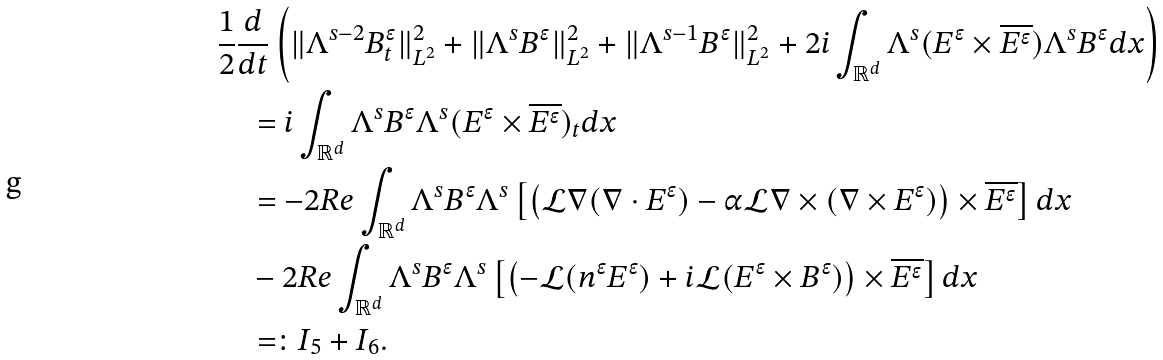<formula> <loc_0><loc_0><loc_500><loc_500>& \frac { 1 } { 2 } \frac { d } { d t } \left ( \| \Lambda ^ { s - 2 } B ^ { \epsilon } _ { t } \| _ { L ^ { 2 } } ^ { 2 } + \| \Lambda ^ { s } B ^ { \epsilon } \| _ { L ^ { 2 } } ^ { 2 } + \| \Lambda ^ { s - 1 } B ^ { \epsilon } \| _ { L ^ { 2 } } ^ { 2 } + 2 i \int _ { \mathbb { R } ^ { d } } \Lambda ^ { s } ( E ^ { \epsilon } \times \overline { E ^ { \epsilon } } ) \Lambda ^ { s } B ^ { \epsilon } d x \right ) \\ & \quad = i \int _ { \mathbb { R } ^ { d } } \Lambda ^ { s } B ^ { \epsilon } \Lambda ^ { s } ( E ^ { \epsilon } \times \overline { E ^ { \epsilon } } ) _ { t } d x \\ & \quad = - 2 R e \int _ { \mathbb { R } ^ { d } } \Lambda ^ { s } B ^ { \epsilon } \Lambda ^ { s } \left [ \left ( \mathcal { L } \nabla ( \nabla \cdot E ^ { \epsilon } ) - \alpha \mathcal { L } \nabla \times ( \nabla \times E ^ { \epsilon } ) \right ) \times \overline { E ^ { \epsilon } } \right ] d x \\ & \quad - 2 R e \int _ { \mathbb { R } ^ { d } } \Lambda ^ { s } B ^ { \epsilon } \Lambda ^ { s } \left [ \left ( - \mathcal { L } ( n ^ { \epsilon } E ^ { \epsilon } ) + i \mathcal { L } ( E ^ { \epsilon } \times B ^ { \epsilon } ) \right ) \times \overline { E ^ { \epsilon } } \right ] d x \\ & \quad = \colon I _ { 5 } + I _ { 6 } .</formula> 